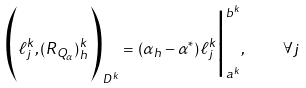Convert formula to latex. <formula><loc_0><loc_0><loc_500><loc_500>\Big ( \ell ^ { k } _ { j } , ( R _ { Q _ { \alpha } } ) ^ { k } _ { h } \Big ) _ { D ^ { k } } = \left ( \alpha _ { h } - \alpha ^ { * } \right ) \ell ^ { k } _ { j } \Big | ^ { b ^ { k } } _ { a ^ { k } } , \quad \forall j</formula> 